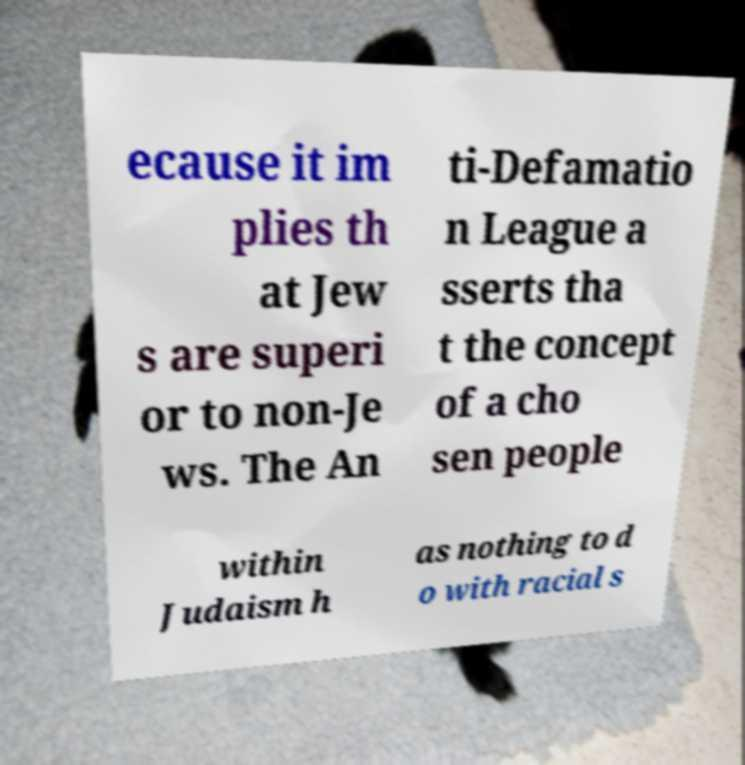Could you assist in decoding the text presented in this image and type it out clearly? ecause it im plies th at Jew s are superi or to non-Je ws. The An ti-Defamatio n League a sserts tha t the concept of a cho sen people within Judaism h as nothing to d o with racial s 